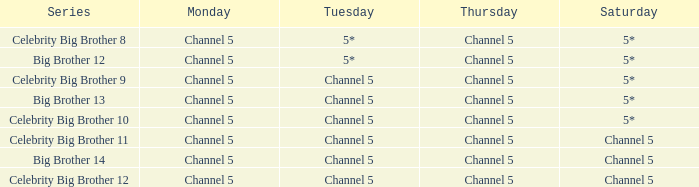Which Thursday does big brother 13 air? Channel 5. 